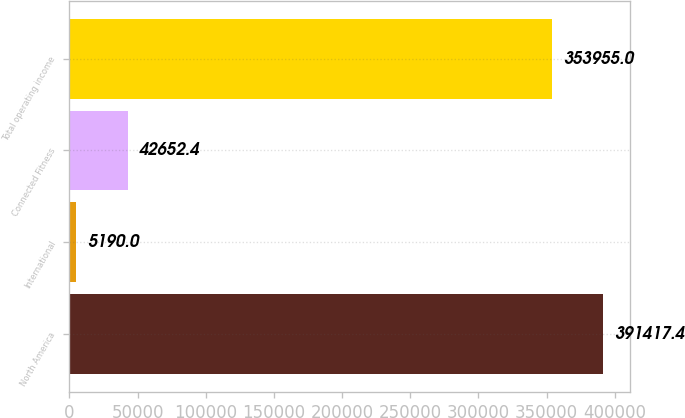Convert chart. <chart><loc_0><loc_0><loc_500><loc_500><bar_chart><fcel>North America<fcel>International<fcel>Connected Fitness<fcel>Total operating income<nl><fcel>391417<fcel>5190<fcel>42652.4<fcel>353955<nl></chart> 